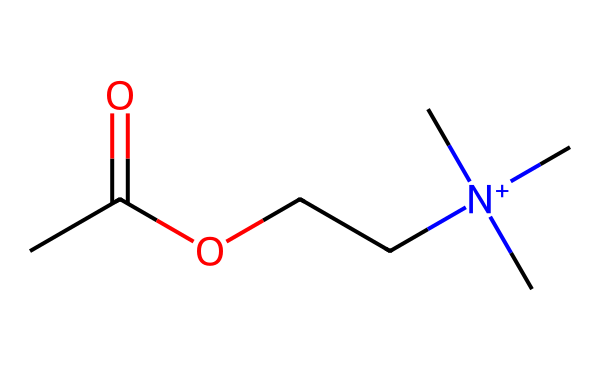What is the molecular formula of acetylcholine? To determine the molecular formula, we identify and count all the atoms from the SMILES representation. From the structure, we have 7 carbon atoms (C), 16 hydrogen atoms (H), 1 nitrogen atom (N), and 2 oxygen atoms (O). Therefore, the molecular formula is C7H16N1O2.
Answer: C7H16N1O2 How many nitrogen atoms are present in acetylcholine? Looking at the SMILES representation, we can identify the presence of one nitrogen atom (N) in the molecule. Therefore, counting it gives us the answer as one nitrogen atom.
Answer: 1 What type of functional groups are present in acetylcholine? In examining the structure, we can identify an acetate group (as indicated by "C(=O)O") and a quaternary ammonium group (due to the positively charged nitrogen with three methyl groups). Therefore, the two functional groups present are acetate and quaternary ammonium.
Answer: acetate and quaternary ammonium How many bonds are between carbon atoms in acetylcholine? In the given SMILES representation, we analyze the carbon connectivity. There are several single bonds and one double bond (C=O) that connects the carbon atoms, amounting to a total of 6 carbon to carbon single bonds.
Answer: 6 What type of neurotransmitter is acetylcholine classified as? The structure shows acetylcholine as a small molecule that serves as a neurotransmitter, specifically nominating it as a cholinergic neurotransmitter due to the presence of a quaternary ammonium. Therefore, it is classified as a cholinergic neurotransmitter.
Answer: cholinergic neurotransmitter Which atoms in acetylcholine are involved in ionic interactions? In acetylcholine, the positively charged nitrogen atom [N+] interacts ionically with negatively charged receptors in the nervous system. Therefore, the nitrogen atom (N) is involved in ionic interactions, while the remaining atoms mainly participate in covalent bonding.
Answer: nitrogen atom 